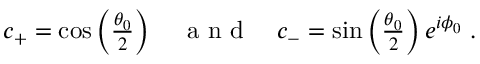Convert formula to latex. <formula><loc_0><loc_0><loc_500><loc_500>\begin{array} { r } { c _ { + } = \cos \left ( \frac { \theta _ { 0 } } { 2 } \right ) \quad a n d \quad c _ { - } = \sin \left ( \frac { \theta _ { 0 } } { 2 } \right ) e ^ { i \phi _ { 0 } } \, . } \end{array}</formula> 